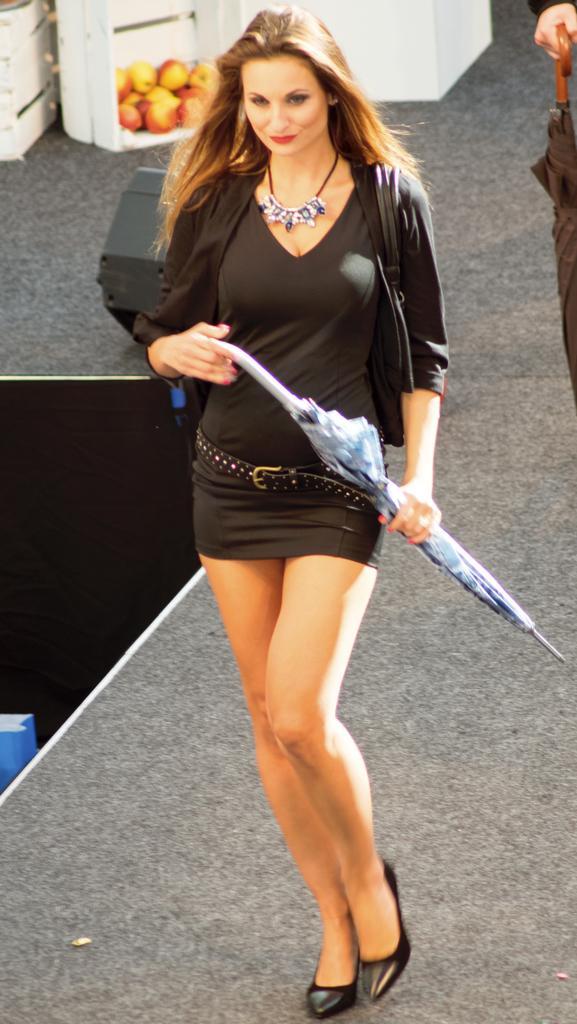In one or two sentences, can you explain what this image depicts? In this picture we can see one woman is standing and holding umbrella. 